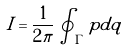<formula> <loc_0><loc_0><loc_500><loc_500>I = \frac { 1 } { 2 \pi } \oint _ { \Gamma } p d q</formula> 